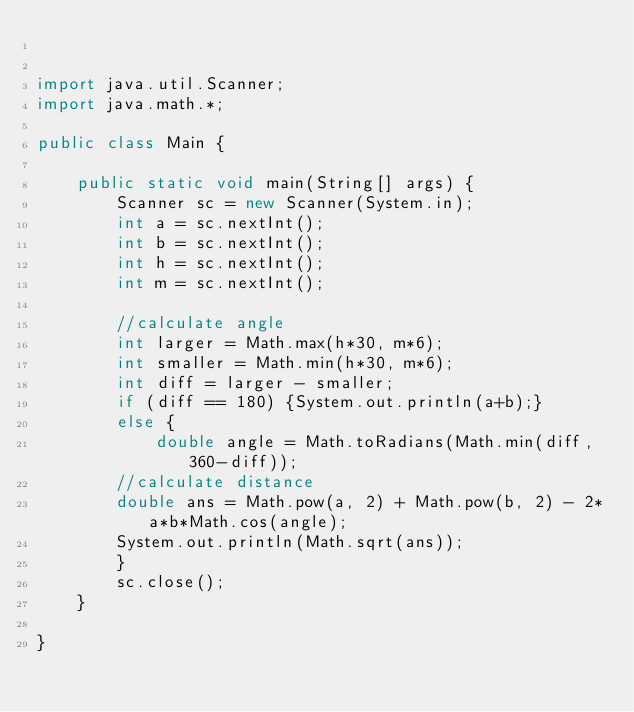Convert code to text. <code><loc_0><loc_0><loc_500><loc_500><_Java_>

import java.util.Scanner;
import java.math.*;

public class Main {

	public static void main(String[] args) {
		Scanner sc = new Scanner(System.in);
		int a = sc.nextInt();
		int b = sc.nextInt();
		int h = sc.nextInt();
		int m = sc.nextInt();
		
		//calculate angle
		int larger = Math.max(h*30, m*6);
		int smaller = Math.min(h*30, m*6);
		int diff = larger - smaller;
		if (diff == 180) {System.out.println(a+b);}
		else {
			double angle = Math.toRadians(Math.min(diff, 360-diff));
		//calculate distance
		double ans = Math.pow(a, 2) + Math.pow(b, 2) - 2*a*b*Math.cos(angle);
		System.out.println(Math.sqrt(ans));
		}
		sc.close();
	}

}
</code> 